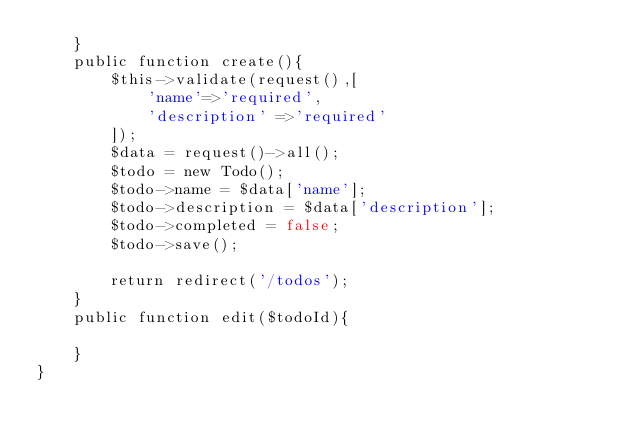Convert code to text. <code><loc_0><loc_0><loc_500><loc_500><_PHP_>    }
    public function create(){
        $this->validate(request(),[
            'name'=>'required',
            'description' =>'required'
        ]);
        $data = request()->all();
        $todo = new Todo();
        $todo->name = $data['name'];
        $todo->description = $data['description'];
        $todo->completed = false;
        $todo->save();

        return redirect('/todos');
    }
    public function edit($todoId){
        
    }
}
</code> 